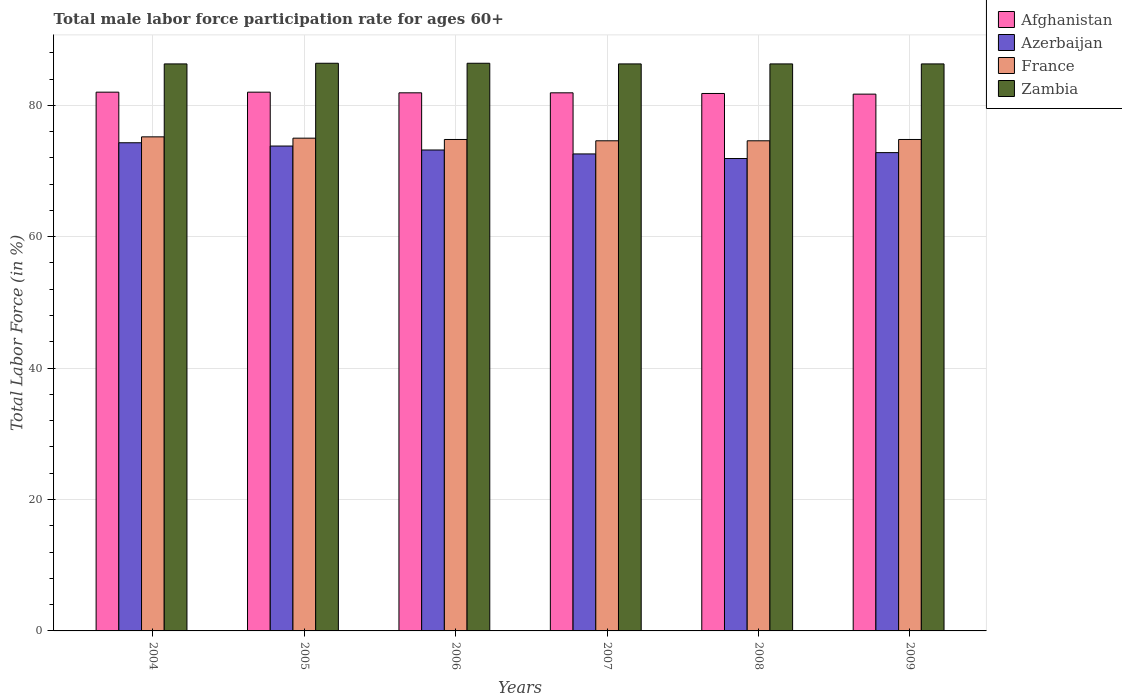Are the number of bars per tick equal to the number of legend labels?
Make the answer very short. Yes. In how many cases, is the number of bars for a given year not equal to the number of legend labels?
Your answer should be compact. 0. What is the male labor force participation rate in Azerbaijan in 2007?
Your answer should be compact. 72.6. Across all years, what is the minimum male labor force participation rate in Azerbaijan?
Give a very brief answer. 71.9. In which year was the male labor force participation rate in France maximum?
Your response must be concise. 2004. In which year was the male labor force participation rate in Afghanistan minimum?
Provide a short and direct response. 2009. What is the total male labor force participation rate in Zambia in the graph?
Keep it short and to the point. 518. What is the difference between the male labor force participation rate in Azerbaijan in 2007 and the male labor force participation rate in Afghanistan in 2009?
Ensure brevity in your answer.  -9.1. What is the average male labor force participation rate in Zambia per year?
Your answer should be very brief. 86.33. In the year 2007, what is the difference between the male labor force participation rate in France and male labor force participation rate in Zambia?
Ensure brevity in your answer.  -11.7. What is the difference between the highest and the second highest male labor force participation rate in Afghanistan?
Give a very brief answer. 0. What is the difference between the highest and the lowest male labor force participation rate in France?
Your response must be concise. 0.6. Is it the case that in every year, the sum of the male labor force participation rate in Azerbaijan and male labor force participation rate in Zambia is greater than the sum of male labor force participation rate in Afghanistan and male labor force participation rate in France?
Offer a terse response. No. What does the 2nd bar from the left in 2008 represents?
Keep it short and to the point. Azerbaijan. What does the 1st bar from the right in 2009 represents?
Your answer should be compact. Zambia. How many bars are there?
Offer a very short reply. 24. How many years are there in the graph?
Your response must be concise. 6. Does the graph contain any zero values?
Give a very brief answer. No. Does the graph contain grids?
Make the answer very short. Yes. How many legend labels are there?
Offer a very short reply. 4. How are the legend labels stacked?
Your answer should be compact. Vertical. What is the title of the graph?
Your answer should be compact. Total male labor force participation rate for ages 60+. Does "Zambia" appear as one of the legend labels in the graph?
Ensure brevity in your answer.  Yes. What is the Total Labor Force (in %) in Afghanistan in 2004?
Provide a short and direct response. 82. What is the Total Labor Force (in %) of Azerbaijan in 2004?
Ensure brevity in your answer.  74.3. What is the Total Labor Force (in %) in France in 2004?
Offer a terse response. 75.2. What is the Total Labor Force (in %) in Zambia in 2004?
Ensure brevity in your answer.  86.3. What is the Total Labor Force (in %) in Azerbaijan in 2005?
Your answer should be compact. 73.8. What is the Total Labor Force (in %) of France in 2005?
Give a very brief answer. 75. What is the Total Labor Force (in %) in Zambia in 2005?
Your answer should be very brief. 86.4. What is the Total Labor Force (in %) of Afghanistan in 2006?
Make the answer very short. 81.9. What is the Total Labor Force (in %) in Azerbaijan in 2006?
Provide a succinct answer. 73.2. What is the Total Labor Force (in %) in France in 2006?
Ensure brevity in your answer.  74.8. What is the Total Labor Force (in %) in Zambia in 2006?
Offer a terse response. 86.4. What is the Total Labor Force (in %) in Afghanistan in 2007?
Provide a succinct answer. 81.9. What is the Total Labor Force (in %) of Azerbaijan in 2007?
Your answer should be very brief. 72.6. What is the Total Labor Force (in %) of France in 2007?
Offer a very short reply. 74.6. What is the Total Labor Force (in %) in Zambia in 2007?
Provide a succinct answer. 86.3. What is the Total Labor Force (in %) of Afghanistan in 2008?
Give a very brief answer. 81.8. What is the Total Labor Force (in %) of Azerbaijan in 2008?
Make the answer very short. 71.9. What is the Total Labor Force (in %) in France in 2008?
Your answer should be compact. 74.6. What is the Total Labor Force (in %) in Zambia in 2008?
Offer a very short reply. 86.3. What is the Total Labor Force (in %) of Afghanistan in 2009?
Keep it short and to the point. 81.7. What is the Total Labor Force (in %) in Azerbaijan in 2009?
Ensure brevity in your answer.  72.8. What is the Total Labor Force (in %) of France in 2009?
Your answer should be very brief. 74.8. What is the Total Labor Force (in %) in Zambia in 2009?
Offer a very short reply. 86.3. Across all years, what is the maximum Total Labor Force (in %) in Afghanistan?
Your answer should be compact. 82. Across all years, what is the maximum Total Labor Force (in %) in Azerbaijan?
Ensure brevity in your answer.  74.3. Across all years, what is the maximum Total Labor Force (in %) in France?
Your answer should be compact. 75.2. Across all years, what is the maximum Total Labor Force (in %) in Zambia?
Ensure brevity in your answer.  86.4. Across all years, what is the minimum Total Labor Force (in %) of Afghanistan?
Ensure brevity in your answer.  81.7. Across all years, what is the minimum Total Labor Force (in %) in Azerbaijan?
Your answer should be compact. 71.9. Across all years, what is the minimum Total Labor Force (in %) of France?
Provide a short and direct response. 74.6. Across all years, what is the minimum Total Labor Force (in %) in Zambia?
Keep it short and to the point. 86.3. What is the total Total Labor Force (in %) in Afghanistan in the graph?
Provide a short and direct response. 491.3. What is the total Total Labor Force (in %) in Azerbaijan in the graph?
Offer a very short reply. 438.6. What is the total Total Labor Force (in %) of France in the graph?
Ensure brevity in your answer.  449. What is the total Total Labor Force (in %) in Zambia in the graph?
Your response must be concise. 518. What is the difference between the Total Labor Force (in %) in Afghanistan in 2004 and that in 2005?
Your answer should be compact. 0. What is the difference between the Total Labor Force (in %) in Azerbaijan in 2004 and that in 2005?
Offer a very short reply. 0.5. What is the difference between the Total Labor Force (in %) in France in 2004 and that in 2005?
Offer a terse response. 0.2. What is the difference between the Total Labor Force (in %) in France in 2004 and that in 2006?
Ensure brevity in your answer.  0.4. What is the difference between the Total Labor Force (in %) of Afghanistan in 2004 and that in 2007?
Your response must be concise. 0.1. What is the difference between the Total Labor Force (in %) in Azerbaijan in 2004 and that in 2007?
Your answer should be compact. 1.7. What is the difference between the Total Labor Force (in %) of France in 2004 and that in 2007?
Ensure brevity in your answer.  0.6. What is the difference between the Total Labor Force (in %) of France in 2004 and that in 2008?
Provide a short and direct response. 0.6. What is the difference between the Total Labor Force (in %) of Zambia in 2004 and that in 2008?
Offer a very short reply. 0. What is the difference between the Total Labor Force (in %) in Afghanistan in 2004 and that in 2009?
Your response must be concise. 0.3. What is the difference between the Total Labor Force (in %) of Azerbaijan in 2004 and that in 2009?
Your response must be concise. 1.5. What is the difference between the Total Labor Force (in %) in France in 2004 and that in 2009?
Keep it short and to the point. 0.4. What is the difference between the Total Labor Force (in %) in Zambia in 2004 and that in 2009?
Keep it short and to the point. 0. What is the difference between the Total Labor Force (in %) in Azerbaijan in 2005 and that in 2006?
Ensure brevity in your answer.  0.6. What is the difference between the Total Labor Force (in %) of Zambia in 2005 and that in 2006?
Offer a terse response. 0. What is the difference between the Total Labor Force (in %) in Afghanistan in 2005 and that in 2007?
Provide a short and direct response. 0.1. What is the difference between the Total Labor Force (in %) of Azerbaijan in 2005 and that in 2007?
Ensure brevity in your answer.  1.2. What is the difference between the Total Labor Force (in %) in France in 2005 and that in 2007?
Your response must be concise. 0.4. What is the difference between the Total Labor Force (in %) of Azerbaijan in 2005 and that in 2008?
Provide a succinct answer. 1.9. What is the difference between the Total Labor Force (in %) of Zambia in 2005 and that in 2008?
Give a very brief answer. 0.1. What is the difference between the Total Labor Force (in %) in France in 2005 and that in 2009?
Keep it short and to the point. 0.2. What is the difference between the Total Labor Force (in %) of Zambia in 2005 and that in 2009?
Ensure brevity in your answer.  0.1. What is the difference between the Total Labor Force (in %) in Afghanistan in 2006 and that in 2007?
Offer a terse response. 0. What is the difference between the Total Labor Force (in %) in Azerbaijan in 2006 and that in 2007?
Offer a terse response. 0.6. What is the difference between the Total Labor Force (in %) in Azerbaijan in 2006 and that in 2008?
Give a very brief answer. 1.3. What is the difference between the Total Labor Force (in %) of France in 2006 and that in 2008?
Your answer should be compact. 0.2. What is the difference between the Total Labor Force (in %) in Afghanistan in 2006 and that in 2009?
Give a very brief answer. 0.2. What is the difference between the Total Labor Force (in %) of Azerbaijan in 2006 and that in 2009?
Provide a short and direct response. 0.4. What is the difference between the Total Labor Force (in %) of France in 2006 and that in 2009?
Make the answer very short. 0. What is the difference between the Total Labor Force (in %) of Zambia in 2006 and that in 2009?
Your response must be concise. 0.1. What is the difference between the Total Labor Force (in %) in France in 2007 and that in 2008?
Your answer should be compact. 0. What is the difference between the Total Labor Force (in %) in Afghanistan in 2007 and that in 2009?
Keep it short and to the point. 0.2. What is the difference between the Total Labor Force (in %) in Azerbaijan in 2007 and that in 2009?
Keep it short and to the point. -0.2. What is the difference between the Total Labor Force (in %) of Afghanistan in 2008 and that in 2009?
Provide a short and direct response. 0.1. What is the difference between the Total Labor Force (in %) of Zambia in 2008 and that in 2009?
Ensure brevity in your answer.  0. What is the difference between the Total Labor Force (in %) of Afghanistan in 2004 and the Total Labor Force (in %) of Azerbaijan in 2005?
Your response must be concise. 8.2. What is the difference between the Total Labor Force (in %) of Afghanistan in 2004 and the Total Labor Force (in %) of France in 2005?
Offer a very short reply. 7. What is the difference between the Total Labor Force (in %) of Azerbaijan in 2004 and the Total Labor Force (in %) of France in 2005?
Your answer should be compact. -0.7. What is the difference between the Total Labor Force (in %) in Azerbaijan in 2004 and the Total Labor Force (in %) in Zambia in 2005?
Your answer should be very brief. -12.1. What is the difference between the Total Labor Force (in %) of Afghanistan in 2004 and the Total Labor Force (in %) of Azerbaijan in 2006?
Make the answer very short. 8.8. What is the difference between the Total Labor Force (in %) in Afghanistan in 2004 and the Total Labor Force (in %) in France in 2006?
Provide a succinct answer. 7.2. What is the difference between the Total Labor Force (in %) in Azerbaijan in 2004 and the Total Labor Force (in %) in Zambia in 2006?
Offer a terse response. -12.1. What is the difference between the Total Labor Force (in %) in Afghanistan in 2004 and the Total Labor Force (in %) in Azerbaijan in 2007?
Make the answer very short. 9.4. What is the difference between the Total Labor Force (in %) of Afghanistan in 2004 and the Total Labor Force (in %) of France in 2007?
Your response must be concise. 7.4. What is the difference between the Total Labor Force (in %) in France in 2004 and the Total Labor Force (in %) in Zambia in 2007?
Ensure brevity in your answer.  -11.1. What is the difference between the Total Labor Force (in %) in Afghanistan in 2004 and the Total Labor Force (in %) in France in 2008?
Provide a succinct answer. 7.4. What is the difference between the Total Labor Force (in %) in Afghanistan in 2004 and the Total Labor Force (in %) in Zambia in 2008?
Your answer should be very brief. -4.3. What is the difference between the Total Labor Force (in %) of Azerbaijan in 2004 and the Total Labor Force (in %) of Zambia in 2008?
Your response must be concise. -12. What is the difference between the Total Labor Force (in %) in Afghanistan in 2004 and the Total Labor Force (in %) in Azerbaijan in 2009?
Your answer should be very brief. 9.2. What is the difference between the Total Labor Force (in %) of Afghanistan in 2004 and the Total Labor Force (in %) of Zambia in 2009?
Offer a very short reply. -4.3. What is the difference between the Total Labor Force (in %) in Azerbaijan in 2004 and the Total Labor Force (in %) in France in 2009?
Ensure brevity in your answer.  -0.5. What is the difference between the Total Labor Force (in %) of France in 2004 and the Total Labor Force (in %) of Zambia in 2009?
Provide a succinct answer. -11.1. What is the difference between the Total Labor Force (in %) of Afghanistan in 2005 and the Total Labor Force (in %) of France in 2006?
Your answer should be very brief. 7.2. What is the difference between the Total Labor Force (in %) of Azerbaijan in 2005 and the Total Labor Force (in %) of France in 2006?
Offer a terse response. -1. What is the difference between the Total Labor Force (in %) of France in 2005 and the Total Labor Force (in %) of Zambia in 2006?
Keep it short and to the point. -11.4. What is the difference between the Total Labor Force (in %) of Azerbaijan in 2005 and the Total Labor Force (in %) of France in 2007?
Ensure brevity in your answer.  -0.8. What is the difference between the Total Labor Force (in %) of Azerbaijan in 2005 and the Total Labor Force (in %) of Zambia in 2007?
Offer a very short reply. -12.5. What is the difference between the Total Labor Force (in %) of Afghanistan in 2005 and the Total Labor Force (in %) of Azerbaijan in 2008?
Provide a short and direct response. 10.1. What is the difference between the Total Labor Force (in %) in Afghanistan in 2005 and the Total Labor Force (in %) in France in 2008?
Ensure brevity in your answer.  7.4. What is the difference between the Total Labor Force (in %) of Azerbaijan in 2005 and the Total Labor Force (in %) of France in 2008?
Ensure brevity in your answer.  -0.8. What is the difference between the Total Labor Force (in %) of Azerbaijan in 2005 and the Total Labor Force (in %) of Zambia in 2008?
Give a very brief answer. -12.5. What is the difference between the Total Labor Force (in %) in Afghanistan in 2005 and the Total Labor Force (in %) in Azerbaijan in 2009?
Keep it short and to the point. 9.2. What is the difference between the Total Labor Force (in %) in Afghanistan in 2006 and the Total Labor Force (in %) in France in 2007?
Make the answer very short. 7.3. What is the difference between the Total Labor Force (in %) of Azerbaijan in 2006 and the Total Labor Force (in %) of France in 2007?
Provide a short and direct response. -1.4. What is the difference between the Total Labor Force (in %) in France in 2006 and the Total Labor Force (in %) in Zambia in 2007?
Give a very brief answer. -11.5. What is the difference between the Total Labor Force (in %) of Afghanistan in 2006 and the Total Labor Force (in %) of France in 2009?
Offer a very short reply. 7.1. What is the difference between the Total Labor Force (in %) in Afghanistan in 2006 and the Total Labor Force (in %) in Zambia in 2009?
Ensure brevity in your answer.  -4.4. What is the difference between the Total Labor Force (in %) of Azerbaijan in 2006 and the Total Labor Force (in %) of France in 2009?
Give a very brief answer. -1.6. What is the difference between the Total Labor Force (in %) of Azerbaijan in 2006 and the Total Labor Force (in %) of Zambia in 2009?
Provide a succinct answer. -13.1. What is the difference between the Total Labor Force (in %) of France in 2006 and the Total Labor Force (in %) of Zambia in 2009?
Ensure brevity in your answer.  -11.5. What is the difference between the Total Labor Force (in %) of Afghanistan in 2007 and the Total Labor Force (in %) of Azerbaijan in 2008?
Your answer should be very brief. 10. What is the difference between the Total Labor Force (in %) of Afghanistan in 2007 and the Total Labor Force (in %) of France in 2008?
Provide a succinct answer. 7.3. What is the difference between the Total Labor Force (in %) of Afghanistan in 2007 and the Total Labor Force (in %) of Zambia in 2008?
Make the answer very short. -4.4. What is the difference between the Total Labor Force (in %) of Azerbaijan in 2007 and the Total Labor Force (in %) of Zambia in 2008?
Make the answer very short. -13.7. What is the difference between the Total Labor Force (in %) of France in 2007 and the Total Labor Force (in %) of Zambia in 2008?
Provide a succinct answer. -11.7. What is the difference between the Total Labor Force (in %) of Afghanistan in 2007 and the Total Labor Force (in %) of France in 2009?
Your answer should be compact. 7.1. What is the difference between the Total Labor Force (in %) of Azerbaijan in 2007 and the Total Labor Force (in %) of Zambia in 2009?
Your answer should be very brief. -13.7. What is the difference between the Total Labor Force (in %) of Afghanistan in 2008 and the Total Labor Force (in %) of Azerbaijan in 2009?
Offer a terse response. 9. What is the difference between the Total Labor Force (in %) of Afghanistan in 2008 and the Total Labor Force (in %) of France in 2009?
Keep it short and to the point. 7. What is the difference between the Total Labor Force (in %) of Azerbaijan in 2008 and the Total Labor Force (in %) of France in 2009?
Your response must be concise. -2.9. What is the difference between the Total Labor Force (in %) of Azerbaijan in 2008 and the Total Labor Force (in %) of Zambia in 2009?
Keep it short and to the point. -14.4. What is the difference between the Total Labor Force (in %) of France in 2008 and the Total Labor Force (in %) of Zambia in 2009?
Ensure brevity in your answer.  -11.7. What is the average Total Labor Force (in %) of Afghanistan per year?
Your response must be concise. 81.88. What is the average Total Labor Force (in %) of Azerbaijan per year?
Keep it short and to the point. 73.1. What is the average Total Labor Force (in %) in France per year?
Offer a very short reply. 74.83. What is the average Total Labor Force (in %) of Zambia per year?
Offer a very short reply. 86.33. In the year 2004, what is the difference between the Total Labor Force (in %) of Afghanistan and Total Labor Force (in %) of Azerbaijan?
Ensure brevity in your answer.  7.7. In the year 2004, what is the difference between the Total Labor Force (in %) of Afghanistan and Total Labor Force (in %) of France?
Give a very brief answer. 6.8. In the year 2004, what is the difference between the Total Labor Force (in %) in Afghanistan and Total Labor Force (in %) in Zambia?
Offer a very short reply. -4.3. In the year 2004, what is the difference between the Total Labor Force (in %) in Azerbaijan and Total Labor Force (in %) in France?
Give a very brief answer. -0.9. In the year 2004, what is the difference between the Total Labor Force (in %) in France and Total Labor Force (in %) in Zambia?
Ensure brevity in your answer.  -11.1. In the year 2005, what is the difference between the Total Labor Force (in %) of Afghanistan and Total Labor Force (in %) of France?
Your answer should be very brief. 7. In the year 2005, what is the difference between the Total Labor Force (in %) of Afghanistan and Total Labor Force (in %) of Zambia?
Make the answer very short. -4.4. In the year 2005, what is the difference between the Total Labor Force (in %) of Azerbaijan and Total Labor Force (in %) of France?
Provide a succinct answer. -1.2. In the year 2006, what is the difference between the Total Labor Force (in %) in Afghanistan and Total Labor Force (in %) in Azerbaijan?
Your answer should be compact. 8.7. In the year 2006, what is the difference between the Total Labor Force (in %) of Afghanistan and Total Labor Force (in %) of Zambia?
Your answer should be very brief. -4.5. In the year 2006, what is the difference between the Total Labor Force (in %) in Azerbaijan and Total Labor Force (in %) in France?
Your answer should be very brief. -1.6. In the year 2006, what is the difference between the Total Labor Force (in %) of Azerbaijan and Total Labor Force (in %) of Zambia?
Make the answer very short. -13.2. In the year 2007, what is the difference between the Total Labor Force (in %) of Afghanistan and Total Labor Force (in %) of Azerbaijan?
Ensure brevity in your answer.  9.3. In the year 2007, what is the difference between the Total Labor Force (in %) in Afghanistan and Total Labor Force (in %) in Zambia?
Your answer should be compact. -4.4. In the year 2007, what is the difference between the Total Labor Force (in %) in Azerbaijan and Total Labor Force (in %) in Zambia?
Keep it short and to the point. -13.7. In the year 2008, what is the difference between the Total Labor Force (in %) in Azerbaijan and Total Labor Force (in %) in France?
Keep it short and to the point. -2.7. In the year 2008, what is the difference between the Total Labor Force (in %) in Azerbaijan and Total Labor Force (in %) in Zambia?
Make the answer very short. -14.4. In the year 2008, what is the difference between the Total Labor Force (in %) in France and Total Labor Force (in %) in Zambia?
Keep it short and to the point. -11.7. In the year 2009, what is the difference between the Total Labor Force (in %) in Afghanistan and Total Labor Force (in %) in Azerbaijan?
Provide a short and direct response. 8.9. In the year 2009, what is the difference between the Total Labor Force (in %) in Afghanistan and Total Labor Force (in %) in France?
Your answer should be compact. 6.9. In the year 2009, what is the difference between the Total Labor Force (in %) in Azerbaijan and Total Labor Force (in %) in Zambia?
Offer a very short reply. -13.5. What is the ratio of the Total Labor Force (in %) of Azerbaijan in 2004 to that in 2005?
Your answer should be very brief. 1.01. What is the ratio of the Total Labor Force (in %) of France in 2004 to that in 2005?
Provide a short and direct response. 1. What is the ratio of the Total Labor Force (in %) in France in 2004 to that in 2006?
Keep it short and to the point. 1.01. What is the ratio of the Total Labor Force (in %) in Zambia in 2004 to that in 2006?
Your answer should be very brief. 1. What is the ratio of the Total Labor Force (in %) in Afghanistan in 2004 to that in 2007?
Your answer should be compact. 1. What is the ratio of the Total Labor Force (in %) in Azerbaijan in 2004 to that in 2007?
Provide a short and direct response. 1.02. What is the ratio of the Total Labor Force (in %) in Zambia in 2004 to that in 2007?
Provide a succinct answer. 1. What is the ratio of the Total Labor Force (in %) in Azerbaijan in 2004 to that in 2008?
Keep it short and to the point. 1.03. What is the ratio of the Total Labor Force (in %) of Afghanistan in 2004 to that in 2009?
Your response must be concise. 1. What is the ratio of the Total Labor Force (in %) in Azerbaijan in 2004 to that in 2009?
Ensure brevity in your answer.  1.02. What is the ratio of the Total Labor Force (in %) in France in 2004 to that in 2009?
Keep it short and to the point. 1.01. What is the ratio of the Total Labor Force (in %) in Azerbaijan in 2005 to that in 2006?
Offer a terse response. 1.01. What is the ratio of the Total Labor Force (in %) in France in 2005 to that in 2006?
Your answer should be very brief. 1. What is the ratio of the Total Labor Force (in %) in Azerbaijan in 2005 to that in 2007?
Give a very brief answer. 1.02. What is the ratio of the Total Labor Force (in %) in France in 2005 to that in 2007?
Offer a terse response. 1.01. What is the ratio of the Total Labor Force (in %) in Azerbaijan in 2005 to that in 2008?
Your answer should be compact. 1.03. What is the ratio of the Total Labor Force (in %) of France in 2005 to that in 2008?
Provide a short and direct response. 1.01. What is the ratio of the Total Labor Force (in %) in Azerbaijan in 2005 to that in 2009?
Provide a short and direct response. 1.01. What is the ratio of the Total Labor Force (in %) of Azerbaijan in 2006 to that in 2007?
Offer a terse response. 1.01. What is the ratio of the Total Labor Force (in %) of France in 2006 to that in 2007?
Give a very brief answer. 1. What is the ratio of the Total Labor Force (in %) of Zambia in 2006 to that in 2007?
Your answer should be very brief. 1. What is the ratio of the Total Labor Force (in %) in Azerbaijan in 2006 to that in 2008?
Your answer should be compact. 1.02. What is the ratio of the Total Labor Force (in %) in France in 2006 to that in 2008?
Your answer should be compact. 1. What is the ratio of the Total Labor Force (in %) of Zambia in 2006 to that in 2008?
Your answer should be very brief. 1. What is the ratio of the Total Labor Force (in %) in Azerbaijan in 2006 to that in 2009?
Make the answer very short. 1.01. What is the ratio of the Total Labor Force (in %) of Zambia in 2006 to that in 2009?
Provide a short and direct response. 1. What is the ratio of the Total Labor Force (in %) in Afghanistan in 2007 to that in 2008?
Keep it short and to the point. 1. What is the ratio of the Total Labor Force (in %) in Azerbaijan in 2007 to that in 2008?
Your answer should be compact. 1.01. What is the ratio of the Total Labor Force (in %) in Zambia in 2007 to that in 2008?
Your response must be concise. 1. What is the ratio of the Total Labor Force (in %) in Afghanistan in 2007 to that in 2009?
Make the answer very short. 1. What is the ratio of the Total Labor Force (in %) in Azerbaijan in 2007 to that in 2009?
Provide a succinct answer. 1. What is the ratio of the Total Labor Force (in %) of France in 2007 to that in 2009?
Give a very brief answer. 1. What is the ratio of the Total Labor Force (in %) in Afghanistan in 2008 to that in 2009?
Keep it short and to the point. 1. What is the ratio of the Total Labor Force (in %) in Azerbaijan in 2008 to that in 2009?
Offer a very short reply. 0.99. What is the difference between the highest and the second highest Total Labor Force (in %) in Azerbaijan?
Ensure brevity in your answer.  0.5. What is the difference between the highest and the second highest Total Labor Force (in %) of France?
Make the answer very short. 0.2. What is the difference between the highest and the second highest Total Labor Force (in %) in Zambia?
Ensure brevity in your answer.  0. 